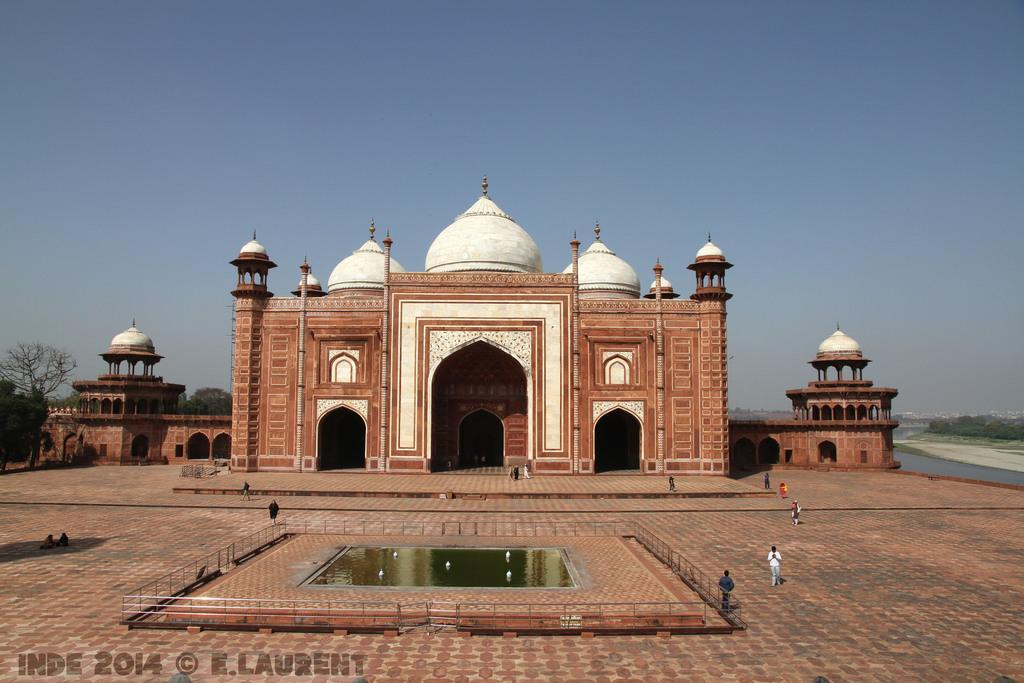What type of structure is present in the image? There is a building in the image. What other natural elements can be seen in the image? There are trees and water visible in the image. What part of the natural environment is visible in the image? The sky is visible in the image. Can you describe the rabbit's digestion process in the image? There is no rabbit present in the image, so it is not possible to describe its digestion process. 